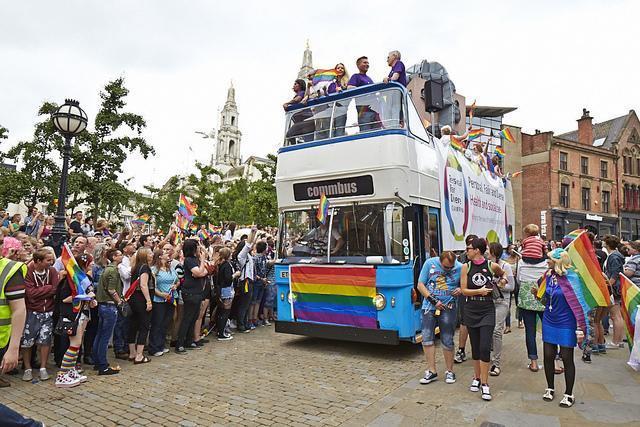How many street lamps are in this scene?
Give a very brief answer. 1. How many people are in the picture?
Give a very brief answer. 8. 